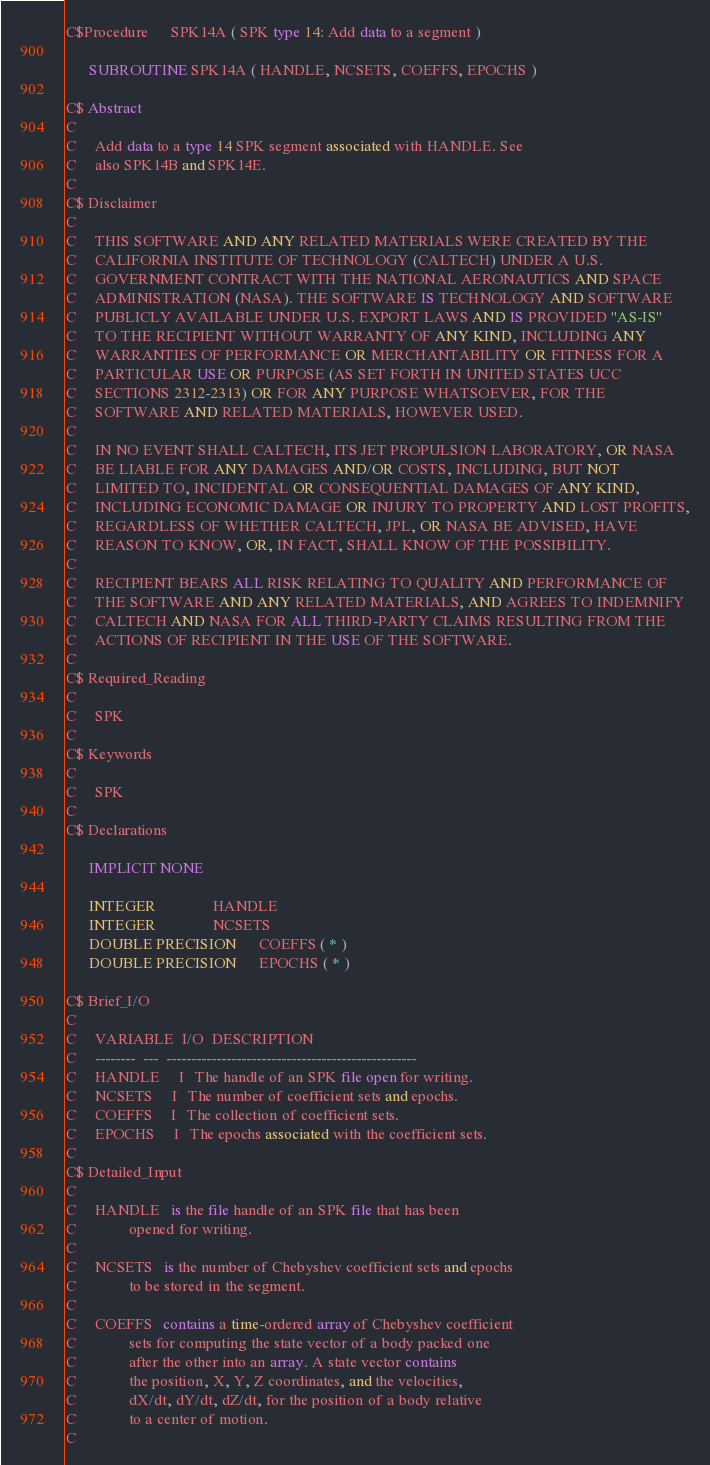<code> <loc_0><loc_0><loc_500><loc_500><_FORTRAN_>C$Procedure      SPK14A ( SPK type 14: Add data to a segment )
 
      SUBROUTINE SPK14A ( HANDLE, NCSETS, COEFFS, EPOCHS )
 
C$ Abstract
C
C     Add data to a type 14 SPK segment associated with HANDLE. See
C     also SPK14B and SPK14E.
C
C$ Disclaimer
C
C     THIS SOFTWARE AND ANY RELATED MATERIALS WERE CREATED BY THE
C     CALIFORNIA INSTITUTE OF TECHNOLOGY (CALTECH) UNDER A U.S.
C     GOVERNMENT CONTRACT WITH THE NATIONAL AERONAUTICS AND SPACE
C     ADMINISTRATION (NASA). THE SOFTWARE IS TECHNOLOGY AND SOFTWARE
C     PUBLICLY AVAILABLE UNDER U.S. EXPORT LAWS AND IS PROVIDED "AS-IS"
C     TO THE RECIPIENT WITHOUT WARRANTY OF ANY KIND, INCLUDING ANY
C     WARRANTIES OF PERFORMANCE OR MERCHANTABILITY OR FITNESS FOR A
C     PARTICULAR USE OR PURPOSE (AS SET FORTH IN UNITED STATES UCC
C     SECTIONS 2312-2313) OR FOR ANY PURPOSE WHATSOEVER, FOR THE
C     SOFTWARE AND RELATED MATERIALS, HOWEVER USED.
C
C     IN NO EVENT SHALL CALTECH, ITS JET PROPULSION LABORATORY, OR NASA
C     BE LIABLE FOR ANY DAMAGES AND/OR COSTS, INCLUDING, BUT NOT
C     LIMITED TO, INCIDENTAL OR CONSEQUENTIAL DAMAGES OF ANY KIND,
C     INCLUDING ECONOMIC DAMAGE OR INJURY TO PROPERTY AND LOST PROFITS,
C     REGARDLESS OF WHETHER CALTECH, JPL, OR NASA BE ADVISED, HAVE
C     REASON TO KNOW, OR, IN FACT, SHALL KNOW OF THE POSSIBILITY.
C
C     RECIPIENT BEARS ALL RISK RELATING TO QUALITY AND PERFORMANCE OF
C     THE SOFTWARE AND ANY RELATED MATERIALS, AND AGREES TO INDEMNIFY
C     CALTECH AND NASA FOR ALL THIRD-PARTY CLAIMS RESULTING FROM THE
C     ACTIONS OF RECIPIENT IN THE USE OF THE SOFTWARE.
C
C$ Required_Reading
C
C     SPK
C
C$ Keywords
C
C     SPK
C
C$ Declarations
 
      IMPLICIT NONE
 
      INTEGER               HANDLE
      INTEGER               NCSETS
      DOUBLE PRECISION      COEFFS ( * )
      DOUBLE PRECISION      EPOCHS ( * )
 
C$ Brief_I/O
C
C     VARIABLE  I/O  DESCRIPTION
C     --------  ---  --------------------------------------------------
C     HANDLE     I   The handle of an SPK file open for writing.
C     NCSETS     I   The number of coefficient sets and epochs.
C     COEFFS     I   The collection of coefficient sets.
C     EPOCHS     I   The epochs associated with the coefficient sets.
C
C$ Detailed_Input
C
C     HANDLE   is the file handle of an SPK file that has been
C              opened for writing.
C
C     NCSETS   is the number of Chebyshev coefficient sets and epochs
C              to be stored in the segment.
C
C     COEFFS   contains a time-ordered array of Chebyshev coefficient
C              sets for computing the state vector of a body packed one
C              after the other into an array. A state vector contains
C              the position, X, Y, Z coordinates, and the velocities,
C              dX/dt, dY/dt, dZ/dt, for the position of a body relative
C              to a center of motion.
C</code> 